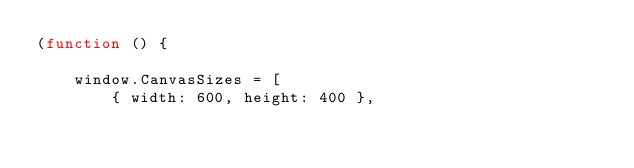Convert code to text. <code><loc_0><loc_0><loc_500><loc_500><_JavaScript_>(function () {

	window.CanvasSizes = [
		{ width: 600, height: 400 },</code> 